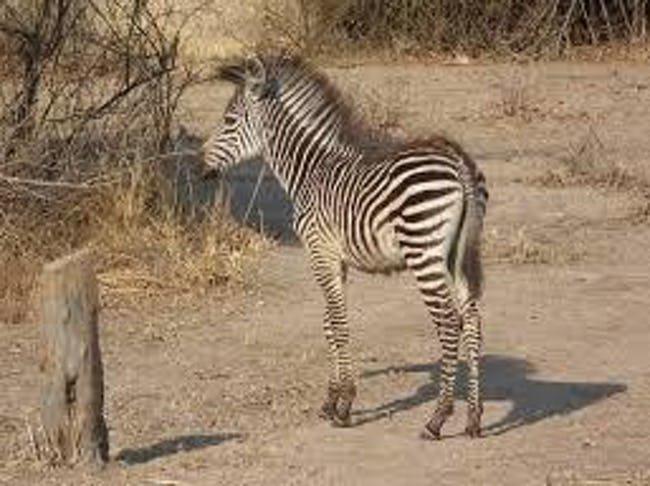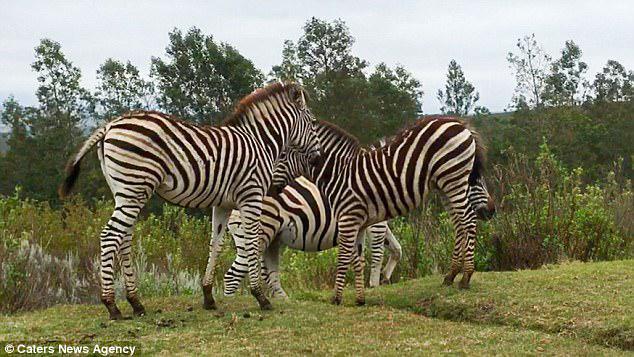The first image is the image on the left, the second image is the image on the right. Analyze the images presented: Is the assertion "The left image includes a zebra colt standing and facing leftward, and the right image contains a rightward-facing zebra standing closest in the foreground." valid? Answer yes or no. Yes. The first image is the image on the left, the second image is the image on the right. Assess this claim about the two images: "In the left image there are two or more zebras moving forward in the same direction.". Correct or not? Answer yes or no. No. 